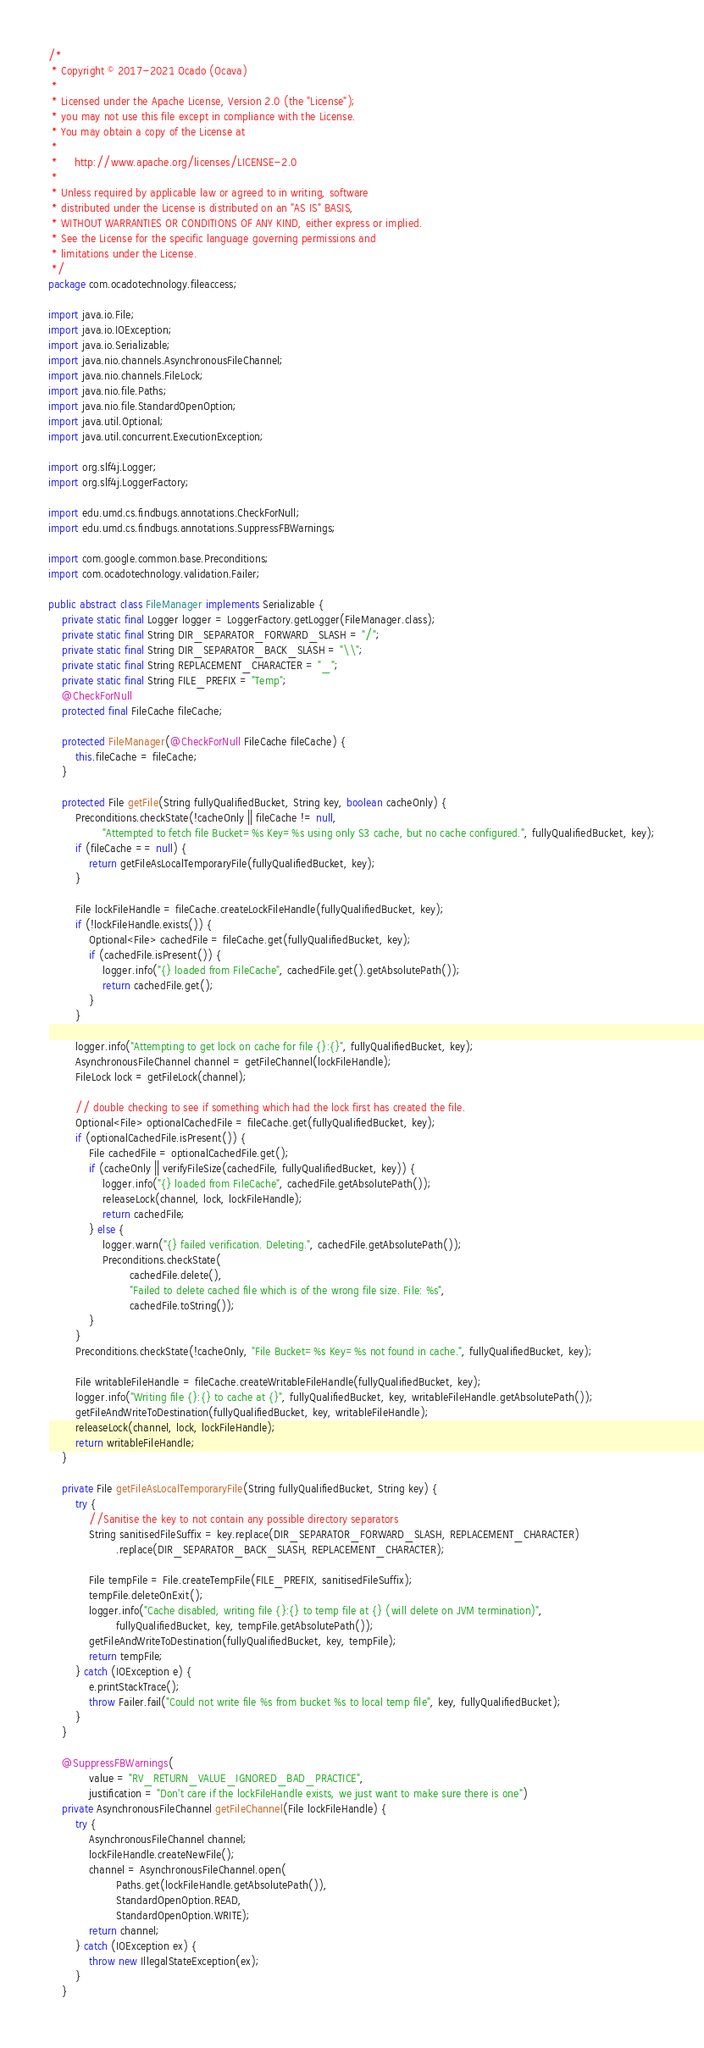<code> <loc_0><loc_0><loc_500><loc_500><_Java_>/*
 * Copyright © 2017-2021 Ocado (Ocava)
 *
 * Licensed under the Apache License, Version 2.0 (the "License");
 * you may not use this file except in compliance with the License.
 * You may obtain a copy of the License at
 *
 *     http://www.apache.org/licenses/LICENSE-2.0
 *
 * Unless required by applicable law or agreed to in writing, software
 * distributed under the License is distributed on an "AS IS" BASIS,
 * WITHOUT WARRANTIES OR CONDITIONS OF ANY KIND, either express or implied.
 * See the License for the specific language governing permissions and
 * limitations under the License.
 */
package com.ocadotechnology.fileaccess;

import java.io.File;
import java.io.IOException;
import java.io.Serializable;
import java.nio.channels.AsynchronousFileChannel;
import java.nio.channels.FileLock;
import java.nio.file.Paths;
import java.nio.file.StandardOpenOption;
import java.util.Optional;
import java.util.concurrent.ExecutionException;

import org.slf4j.Logger;
import org.slf4j.LoggerFactory;

import edu.umd.cs.findbugs.annotations.CheckForNull;
import edu.umd.cs.findbugs.annotations.SuppressFBWarnings;

import com.google.common.base.Preconditions;
import com.ocadotechnology.validation.Failer;

public abstract class FileManager implements Serializable {
    private static final Logger logger = LoggerFactory.getLogger(FileManager.class);
    private static final String DIR_SEPARATOR_FORWARD_SLASH = "/";
    private static final String DIR_SEPARATOR_BACK_SLASH = "\\";
    private static final String REPLACEMENT_CHARACTER = "_";
    private static final String FILE_PREFIX = "Temp";
    @CheckForNull
    protected final FileCache fileCache;

    protected FileManager(@CheckForNull FileCache fileCache) {
        this.fileCache = fileCache;
    }

    protected File getFile(String fullyQualifiedBucket, String key, boolean cacheOnly) {
        Preconditions.checkState(!cacheOnly || fileCache != null,
                "Attempted to fetch file Bucket=%s Key=%s using only S3 cache, but no cache configured.", fullyQualifiedBucket, key);
        if (fileCache == null) {
            return getFileAsLocalTemporaryFile(fullyQualifiedBucket, key);
        }

        File lockFileHandle = fileCache.createLockFileHandle(fullyQualifiedBucket, key);
        if (!lockFileHandle.exists()) {
            Optional<File> cachedFile = fileCache.get(fullyQualifiedBucket, key);
            if (cachedFile.isPresent()) {
                logger.info("{} loaded from FileCache", cachedFile.get().getAbsolutePath());
                return cachedFile.get();
            }
        }

        logger.info("Attempting to get lock on cache for file {}:{}", fullyQualifiedBucket, key);
        AsynchronousFileChannel channel = getFileChannel(lockFileHandle);
        FileLock lock = getFileLock(channel);

        // double checking to see if something which had the lock first has created the file.
        Optional<File> optionalCachedFile = fileCache.get(fullyQualifiedBucket, key);
        if (optionalCachedFile.isPresent()) {
            File cachedFile = optionalCachedFile.get();
            if (cacheOnly || verifyFileSize(cachedFile, fullyQualifiedBucket, key)) {
                logger.info("{} loaded from FileCache", cachedFile.getAbsolutePath());
                releaseLock(channel, lock, lockFileHandle);
                return cachedFile;
            } else {
                logger.warn("{} failed verification. Deleting.", cachedFile.getAbsolutePath());
                Preconditions.checkState(
                        cachedFile.delete(),
                        "Failed to delete cached file which is of the wrong file size. File: %s",
                        cachedFile.toString());
            }
        }
        Preconditions.checkState(!cacheOnly, "File Bucket=%s Key=%s not found in cache.", fullyQualifiedBucket, key);

        File writableFileHandle = fileCache.createWritableFileHandle(fullyQualifiedBucket, key);
        logger.info("Writing file {}:{} to cache at {}", fullyQualifiedBucket, key, writableFileHandle.getAbsolutePath());
        getFileAndWriteToDestination(fullyQualifiedBucket, key, writableFileHandle);
        releaseLock(channel, lock, lockFileHandle);
        return writableFileHandle;
    }

    private File getFileAsLocalTemporaryFile(String fullyQualifiedBucket, String key) {
        try {
            //Sanitise the key to not contain any possible directory separators
            String sanitisedFileSuffix = key.replace(DIR_SEPARATOR_FORWARD_SLASH, REPLACEMENT_CHARACTER)
                    .replace(DIR_SEPARATOR_BACK_SLASH, REPLACEMENT_CHARACTER);

            File tempFile = File.createTempFile(FILE_PREFIX, sanitisedFileSuffix);
            tempFile.deleteOnExit();
            logger.info("Cache disabled, writing file {}:{} to temp file at {} (will delete on JVM termination)",
                    fullyQualifiedBucket, key, tempFile.getAbsolutePath());
            getFileAndWriteToDestination(fullyQualifiedBucket, key, tempFile);
            return tempFile;
        } catch (IOException e) {
            e.printStackTrace();
            throw Failer.fail("Could not write file %s from bucket %s to local temp file", key, fullyQualifiedBucket);
        }
    }

    @SuppressFBWarnings(
            value = "RV_RETURN_VALUE_IGNORED_BAD_PRACTICE",
            justification = "Don't care if the lockFileHandle exists, we just want to make sure there is one")
    private AsynchronousFileChannel getFileChannel(File lockFileHandle) {
        try {
            AsynchronousFileChannel channel;
            lockFileHandle.createNewFile();
            channel = AsynchronousFileChannel.open(
                    Paths.get(lockFileHandle.getAbsolutePath()),
                    StandardOpenOption.READ,
                    StandardOpenOption.WRITE);
            return channel;
        } catch (IOException ex) {
            throw new IllegalStateException(ex);
        }
    }
</code> 